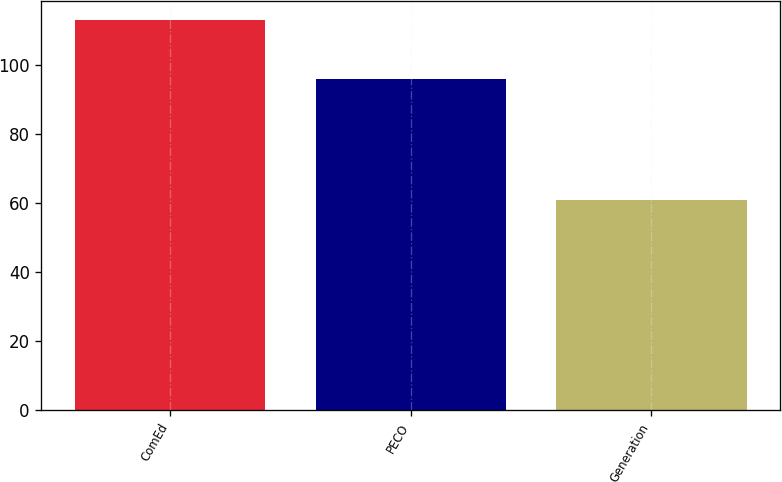Convert chart to OTSL. <chart><loc_0><loc_0><loc_500><loc_500><bar_chart><fcel>ComEd<fcel>PECO<fcel>Generation<nl><fcel>113<fcel>96<fcel>61<nl></chart> 